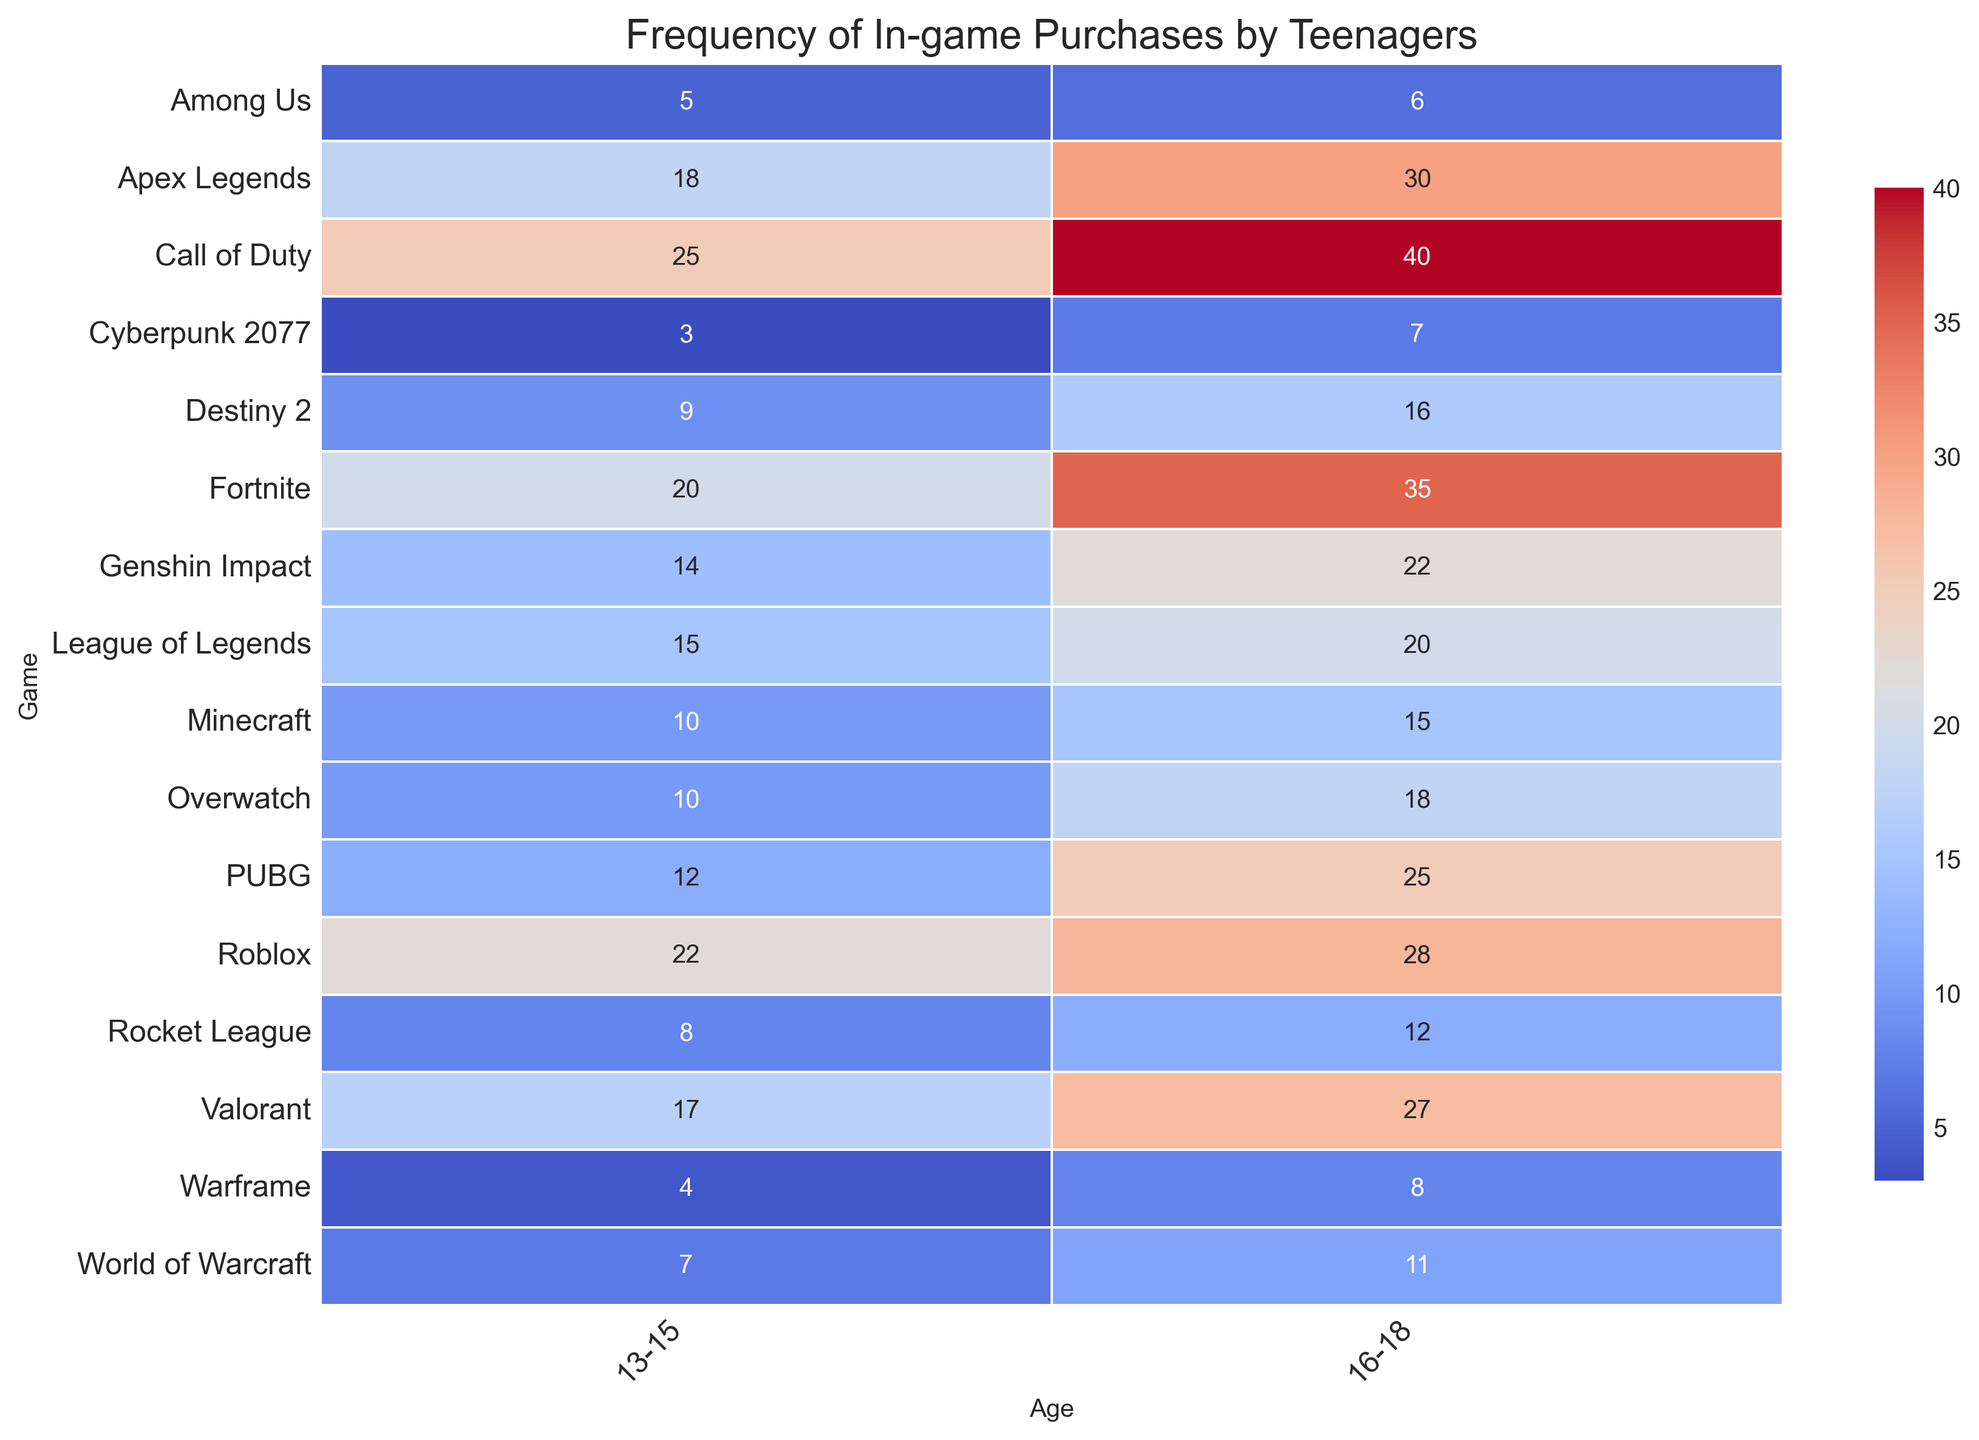What's the frequency of in-game purchases for Call of Duty by teenagers aged 16-18? Locate the cell corresponding to Call of Duty and the age group 16-18. The value in the cell is 40.
Answer: 40 Which game has the highest frequency of in-game purchases for teenagers aged 13-15? Look at the column for 13-15 and find the highest number. The highest number is 25, corresponding to Call of Duty.
Answer: Call of Duty What is the difference in frequency of in-game purchases between Fortnite and Minecraft for teenagers aged 16-18? Identify the values for Fortnite (35) and Minecraft (15) in the 16-18 age group. The difference is 35 - 15 = 20.
Answer: 20 Which age group, 13-15 or 16-18, has a higher overall frequency of in-game purchases for Valorant? Look at the values for Valorant across both age groups: 13-15 has 17 and 16-18 has 27. Since 27 is greater, 16-18 has a higher frequency.
Answer: 16-18 What's the combined frequency of in-game purchases for Roblox and PUBG for teenagers aged 16-18? Add the values for Roblox (28) and PUBG (25) in the age group 16-18. The sum is 28 + 25 = 53.
Answer: 53 How many games have a higher frequency of in-game purchases for teenagers aged 13-15 compared to 16-18? Compare the values for each game across the two age groups. Only Fortnite (20 vs 35), Call of Duty (25 vs 40), and Apex Legends (18 vs 30) have a higher frequency for 16-18, so 0 games have a higher frequency for 13-15.
Answer: 0 What is the average frequency of in-game purchases for Among Us across both age groups? Add the values for Among Us for both age groups (5 for 13-15 and 6 for 16-18) and divide by 2. (5 + 6) / 2 = 5.5.
Answer: 5.5 Identify the game with the lowest frequency of in-game purchases in both age groups combined. Find the minimum value in both the 13-15 and 16-18 columns: Cyberpunk 2077 has 3 for 13-15 and 7 for 16-18, combining to 10.
Answer: Cyberpunk 2077 Which games have the same frequency of in-game purchases for both age groups? Find games where the values in both age columns are the same. None of the games have the same values in both age groups.
Answer: None What is the overall sum of in-game purchases for World of Warcraft for teenagers aged 13-15 and Apex Legends for teenagers aged 16-18? Add the values for World of Warcraft (7) in 13-15 and Apex Legends (30) in 16-18. The sum is 7 + 30 = 37.
Answer: 37 